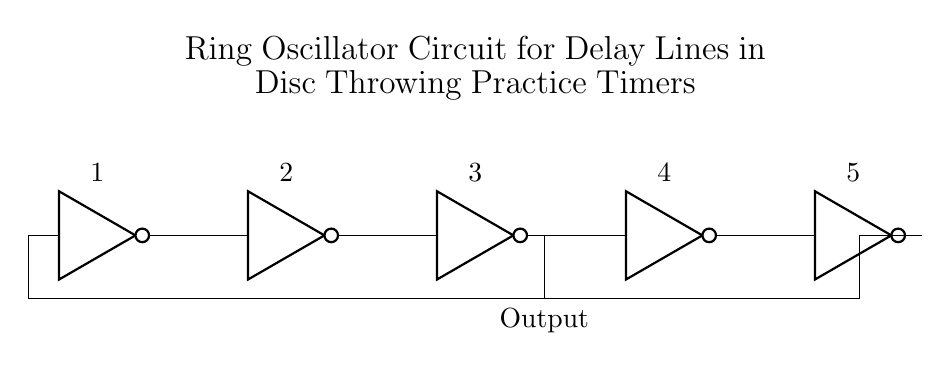What type of gates are used in this circuit? The circuit consists of five NOT gates, which are indicated by the "not port" symbols in the diagram. Each gate is labeled sequentially from one to five.
Answer: NOT gates How many NOT gates are in this ring oscillator? The diagram shows a total of five NOT gates connected in a series arrangement, which forms a circular feedback loop essential for the operation of the ring oscillator.
Answer: Five What is the main output label in the circuit? The output from the third NOT gate is labeled as "Output," indicating where the delay signal can be taken for use in the disc throwing practice timer.
Answer: Output What is the function of this circuit? The primary function of this ring oscillator is to generate delays in the output signal, which can be useful for timing events in disc throwing practices, providing a precision timing mechanism.
Answer: Generate delays Which NOT gate is the output taken from? The output of the circuit is taken from the third NOT gate in the series, as indicated by the arrow pointing downwards to the label "Output" below it.
Answer: Third NOT gate How do the NOT gates connect to form a ring oscillator? The NOT gates are connected in series, with the output of the last NOT gate feeding back into the first NOT gate. This configuration creates a continuous loop that oscillates, generating the desired timing delays.
Answer: Series connections What role do the NOT gates play in creating the delay? Each NOT gate introduces a phase shift in the signal, and the combination of multiple NOT gates creates cumulative delays, resulting in a longer overall delay time which can be adjusted based on the number of gates used.
Answer: Introduce phase shifts 